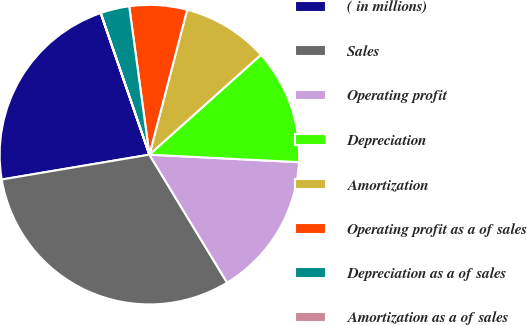Convert chart to OTSL. <chart><loc_0><loc_0><loc_500><loc_500><pie_chart><fcel>( in millions)<fcel>Sales<fcel>Operating profit<fcel>Depreciation<fcel>Amortization<fcel>Operating profit as a of sales<fcel>Depreciation as a of sales<fcel>Amortization as a of sales<nl><fcel>22.38%<fcel>31.03%<fcel>15.52%<fcel>12.42%<fcel>9.32%<fcel>6.21%<fcel>3.11%<fcel>0.01%<nl></chart> 